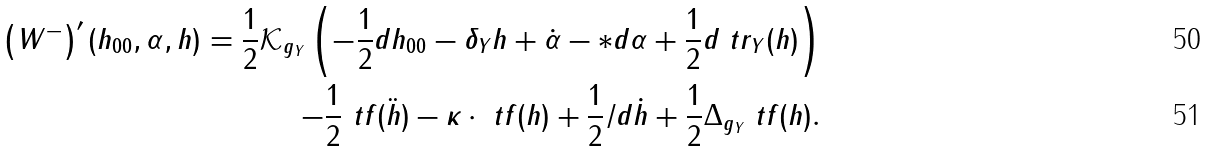Convert formula to latex. <formula><loc_0><loc_0><loc_500><loc_500>\left ( W ^ { - } \right ) ^ { \prime } ( h _ { 0 0 } , \alpha , h ) = \frac { 1 } { 2 } \mathcal { K } _ { g _ { Y } } \left ( - \frac { 1 } { 2 } d h _ { 0 0 } - \delta _ { Y } h + \dot { \alpha } - * d \alpha + \frac { 1 } { 2 } d \ t r _ { Y } ( h ) \right ) \\ - \frac { 1 } { 2 } \ t f ( \ddot { h } ) - \kappa \cdot \ t f ( h ) + \frac { 1 } { 2 } { \slash d } \dot { h } + \frac { 1 } { 2 } \Delta _ { g _ { Y } } \ t f ( h ) .</formula> 